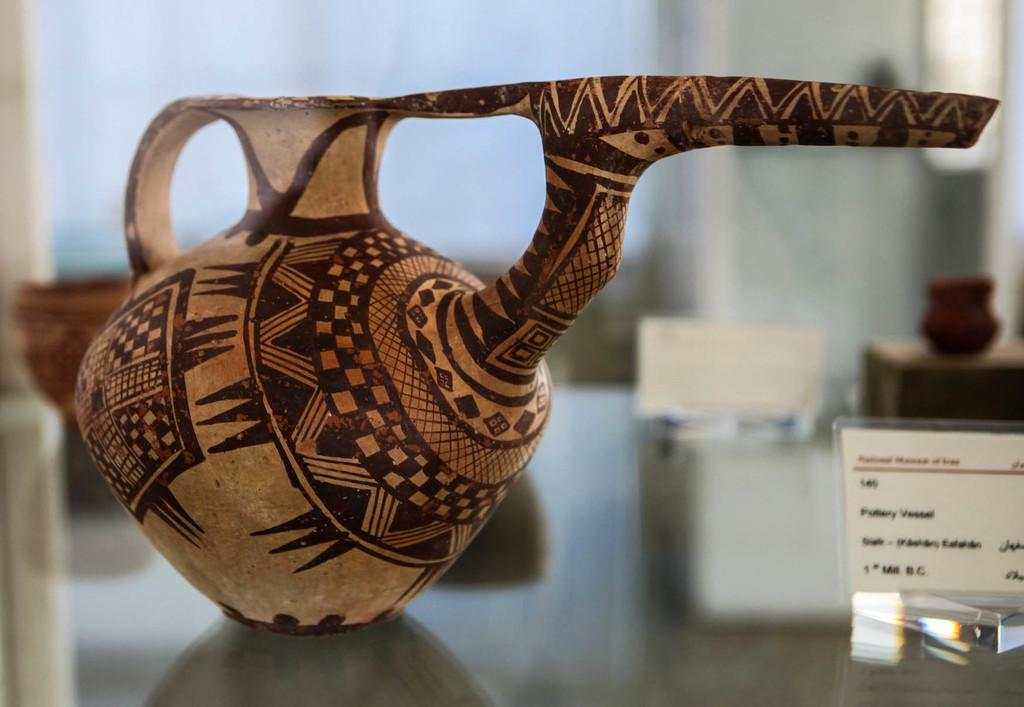What type of object is in the image? There is an earthenware in the image. Where is the earthenware located? The earthenware is placed on a table. What can be seen on the right side of the image? There is a white color card on the right side of the image. What is written or printed on the card? There is text on the card. How would you describe the background of the image? The background of the image is blurred. How many chickens are present in the image? There are no chickens present in the image. What type of meal is being prepared on the table in the image? There is no meal preparation visible in the image; it only shows an earthenware on a table. 